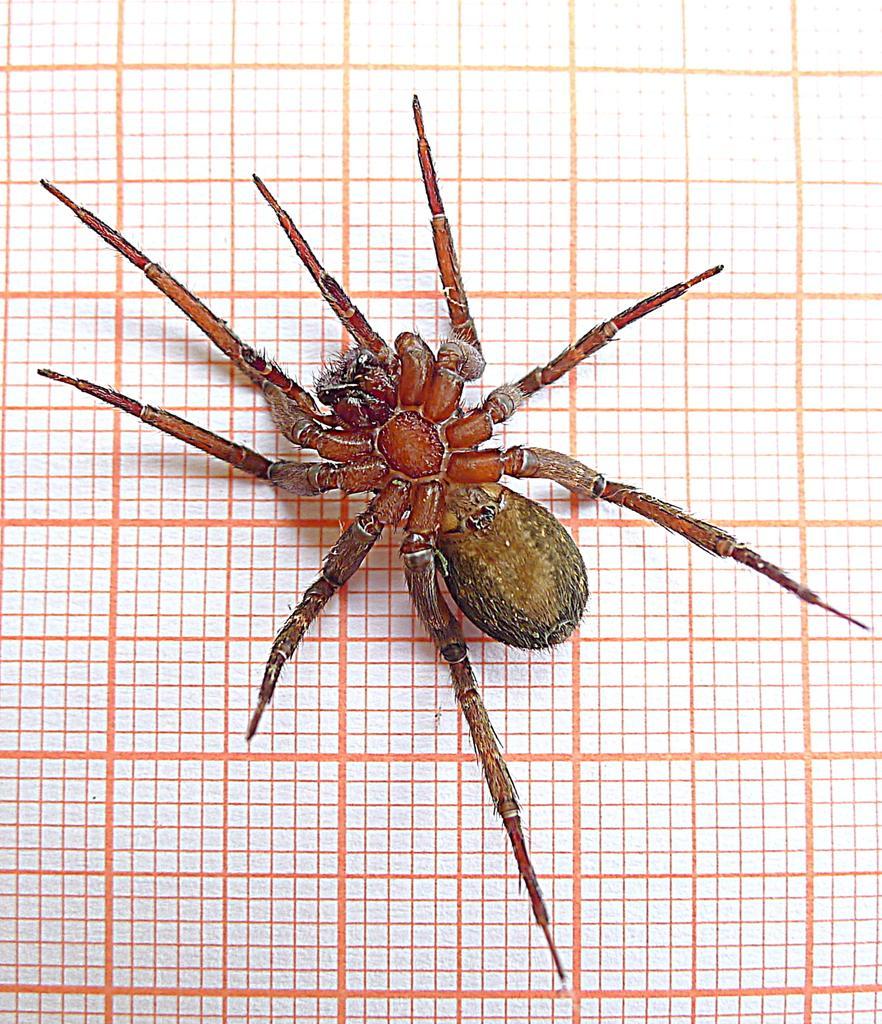Can you describe this image briefly? In this image I can see a spider on a fence. This image is taken may be during a day. 